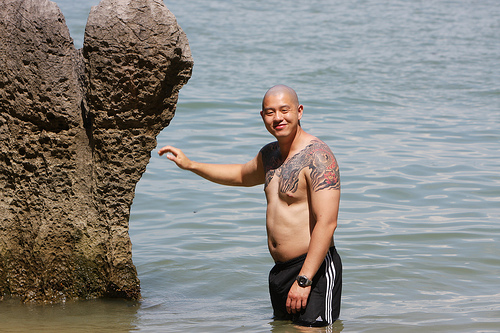<image>
Is there a man to the right of the rock? Yes. From this viewpoint, the man is positioned to the right side relative to the rock. 